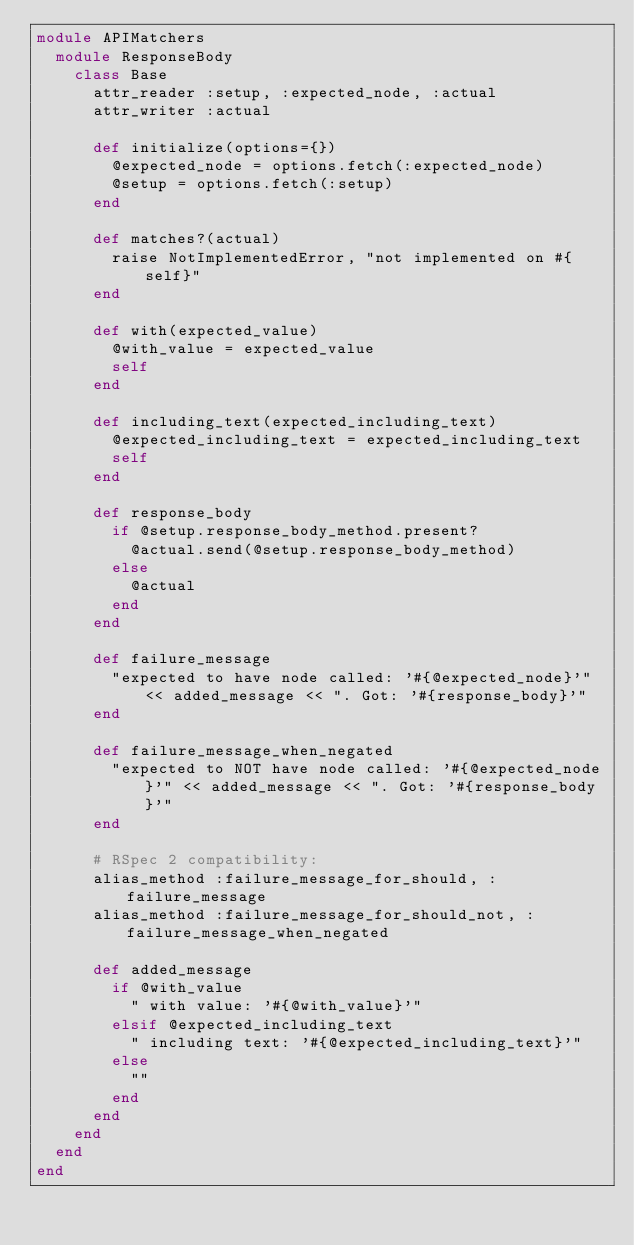<code> <loc_0><loc_0><loc_500><loc_500><_Ruby_>module APIMatchers
  module ResponseBody
    class Base
      attr_reader :setup, :expected_node, :actual
      attr_writer :actual

      def initialize(options={})
        @expected_node = options.fetch(:expected_node)
        @setup = options.fetch(:setup)
      end

      def matches?(actual)
        raise NotImplementedError, "not implemented on #{self}"
      end

      def with(expected_value)
        @with_value = expected_value
        self
      end

      def including_text(expected_including_text)
        @expected_including_text = expected_including_text
        self
      end

      def response_body
        if @setup.response_body_method.present?
          @actual.send(@setup.response_body_method)
        else
          @actual
        end
      end

      def failure_message
        "expected to have node called: '#{@expected_node}'" << added_message << ". Got: '#{response_body}'"
      end

      def failure_message_when_negated
        "expected to NOT have node called: '#{@expected_node}'" << added_message << ". Got: '#{response_body}'"
      end

      # RSpec 2 compatibility:
      alias_method :failure_message_for_should, :failure_message
      alias_method :failure_message_for_should_not, :failure_message_when_negated

      def added_message
        if @with_value
          " with value: '#{@with_value}'"
        elsif @expected_including_text
          " including text: '#{@expected_including_text}'"
        else
          ""
        end
      end
    end
  end
end
</code> 